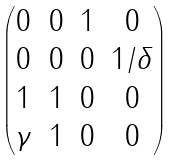<formula> <loc_0><loc_0><loc_500><loc_500>\begin{pmatrix} 0 & 0 & 1 & 0 \\ 0 & 0 & 0 & 1 / \delta \\ 1 & 1 & 0 & 0 \\ \gamma & 1 & 0 & 0 \end{pmatrix}</formula> 